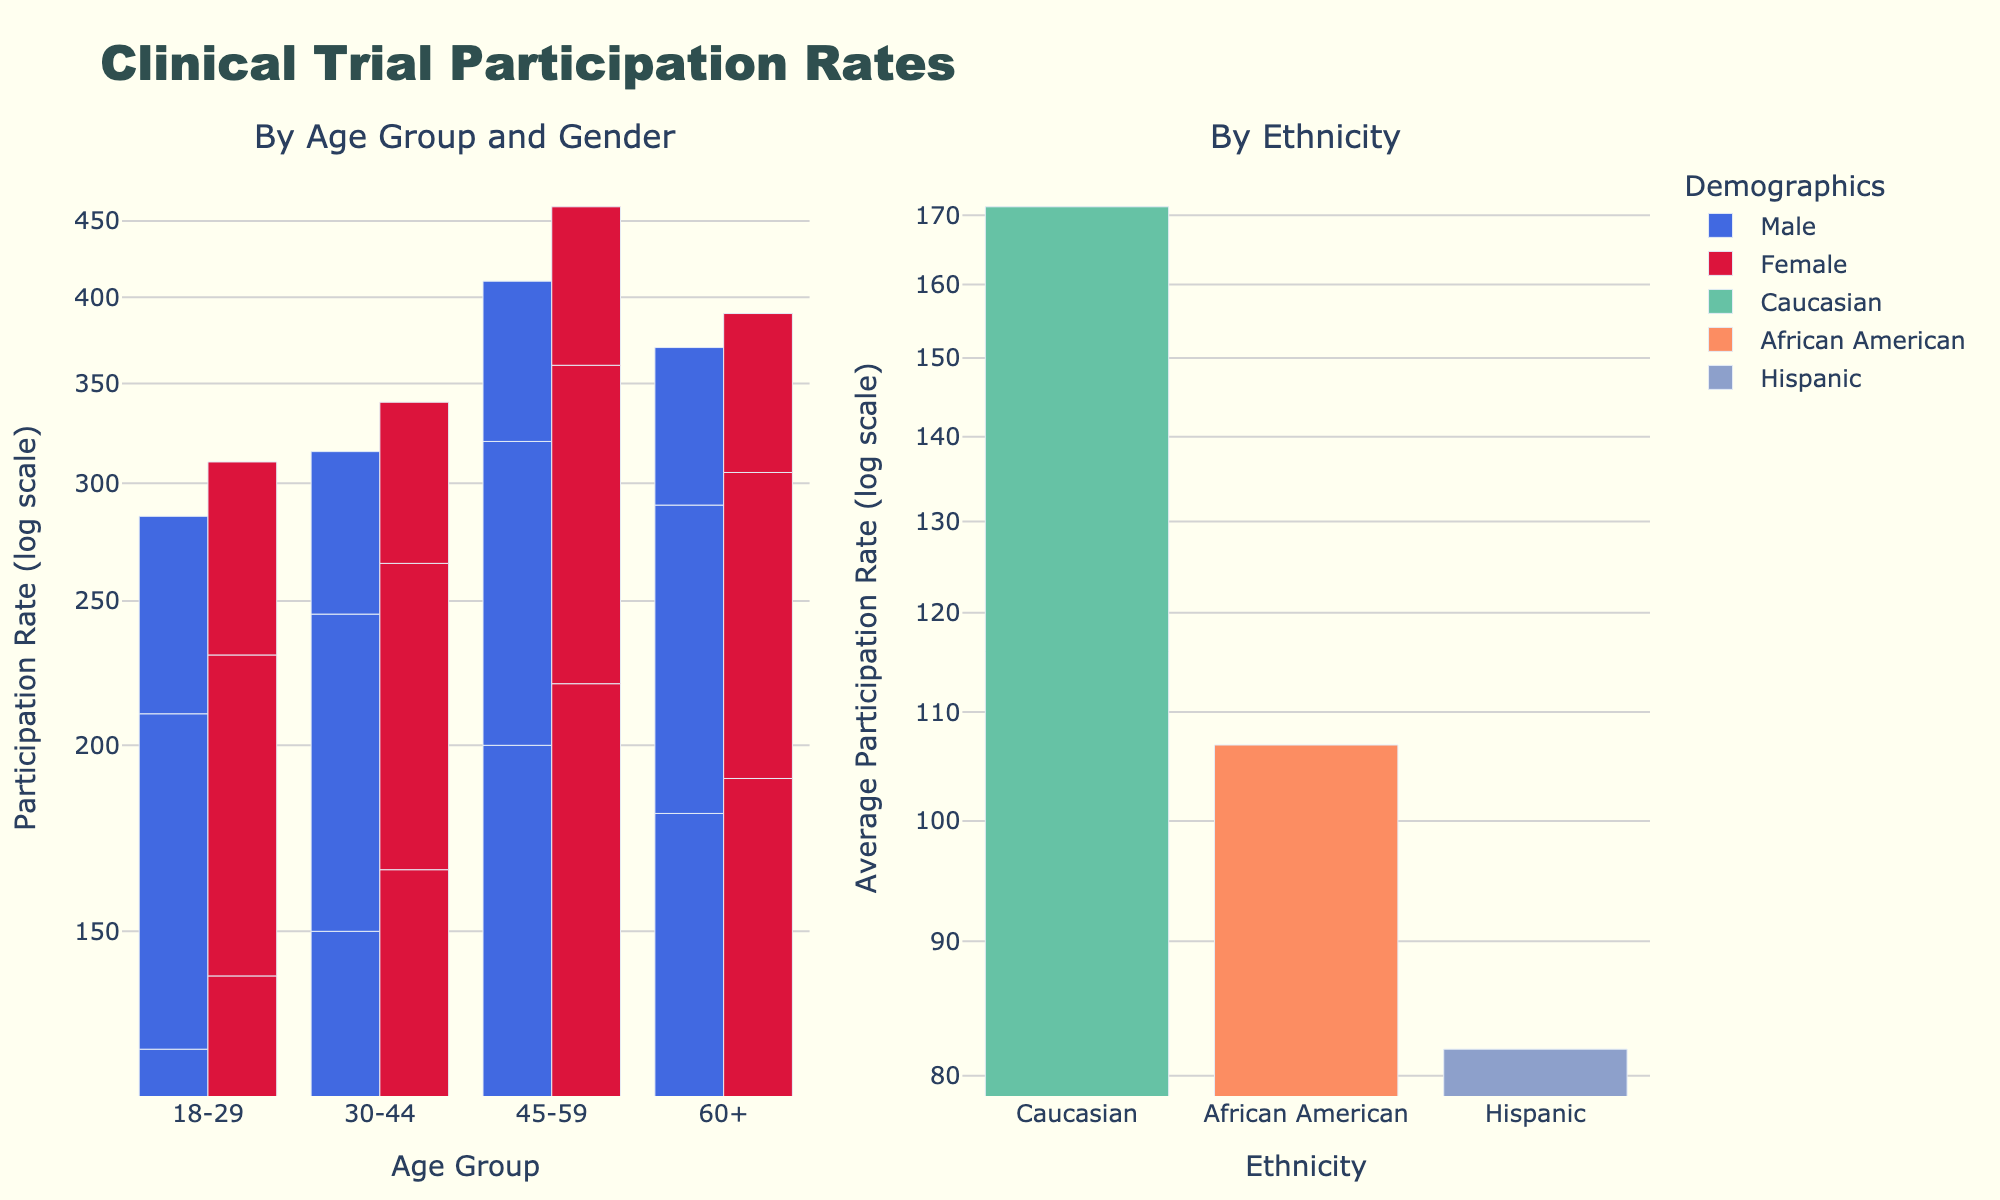What is the title of the figure? The title of the figure is located at the top center and is typically the most prominent text in the figure. The title for this figure is "Clinical Trial Participation Rates."
Answer: Clinical Trial Participation Rates What axis is represented on a log scale in this figure? Since the y-axis is labeled "Participation Rate (log scale)" and "Average Participation Rate (log scale)" in the two subplots, it indicates that the y-axis is on a log scale.
Answer: Y-axis How many age groups are displayed in the left subplot? The x-axis of the left subplot is labeled "Age Group" and has four age categories: 18-29, 30-44, 45-59, and 60+. Thus, there are four age groups displayed in the left subplot.
Answer: Four What is the average participation rate for Hispanic participants across all age groups? The right subplot shows bars for different ethnicities, and the bar labeled "Hispanic" represents the average participation rate across all age groups. The axis value of this bar gives the answer.
Answer: About 100 Which age group has the highest participation rate? By comparing the heights of the bars in the left subplot, we see that the 45-59 age group has the highest participation rate since its bars are the tallest.
Answer: 45-59 How does participation rate differ between male and female participants in the 30-44 age group? In the left subplot, we compare the heights of the bars labeled for males and females within the 30-44 age group. The female participation rate bar is slightly higher than the male bar.
Answer: Females have a higher participation rate Which group has the lowest participation rate, and what is that rate? By finding the shortest bar in the entire figure, we see it belongs to "18-29 Male Hispanic" in the left subplot with a very low log-scale value.
Answer: 75 Is the participation rate for African American participants in the 60+ age group higher or lower than the rate for Caucasian participants of the same age group? Compare the bars for "60+" in the left subplot for African American Male and Caucasian Male. The Caucasian Male bar is higher than the African American Male bar.
Answer: Lower What is the general trend of participation rates with age regardless of gender and ethnicity? Observing the left subplot, we can see a general trend of increasing bar heights as the age group increases from 18-29 to 60+.
Answer: Participation rates generally increase with age Does any ethnicity in the right subplot have a significantly higher participation rate compared to others? Look at the heights of the bars in the right subplot. Caucasian participants have notably higher bars compared to other ethnicities.
Answer: Caucasian 